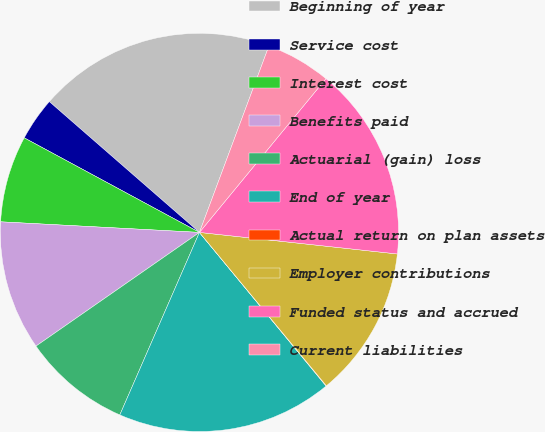<chart> <loc_0><loc_0><loc_500><loc_500><pie_chart><fcel>Beginning of year<fcel>Service cost<fcel>Interest cost<fcel>Benefits paid<fcel>Actuarial (gain) loss<fcel>End of year<fcel>Actual return on plan assets<fcel>Employer contributions<fcel>Funded status and accrued<fcel>Current liabilities<nl><fcel>19.27%<fcel>3.53%<fcel>7.03%<fcel>10.52%<fcel>8.78%<fcel>17.52%<fcel>0.03%<fcel>12.27%<fcel>15.77%<fcel>5.28%<nl></chart> 